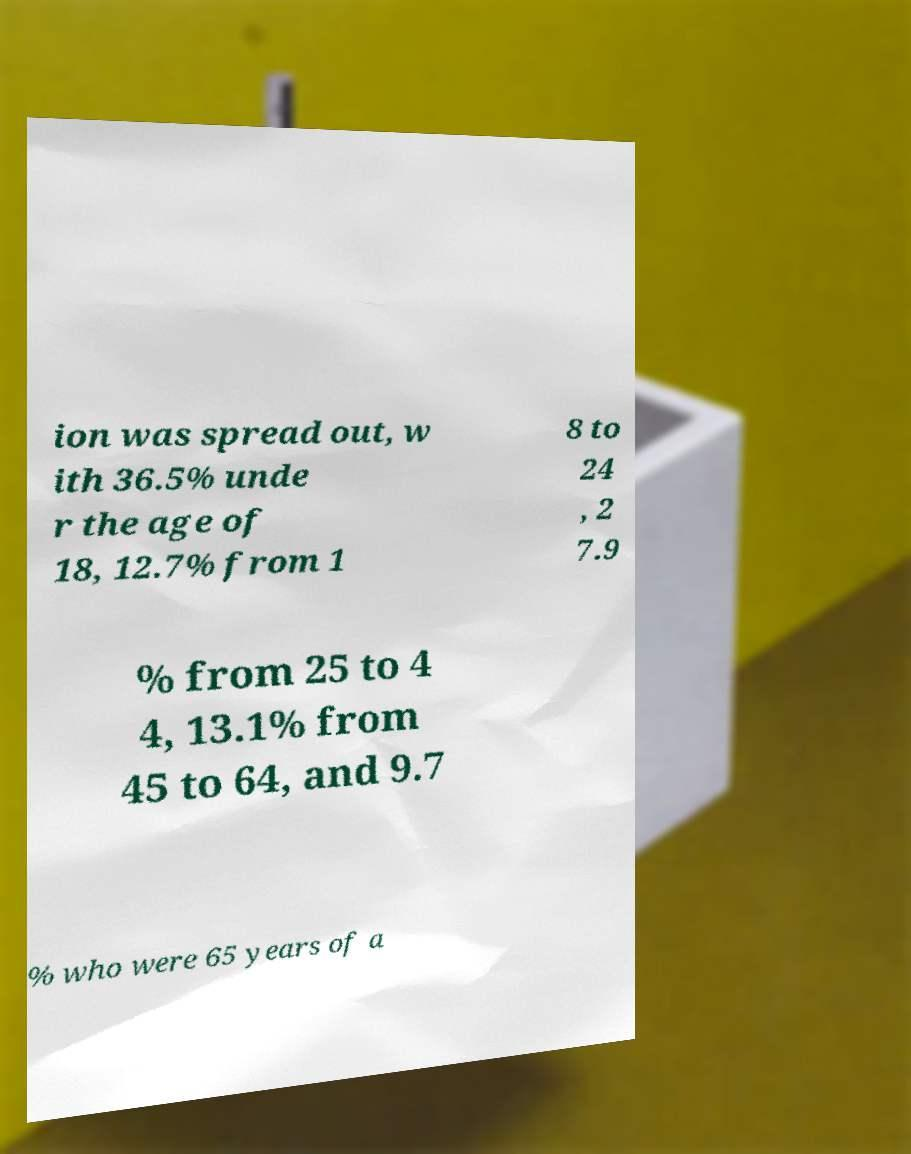Could you assist in decoding the text presented in this image and type it out clearly? ion was spread out, w ith 36.5% unde r the age of 18, 12.7% from 1 8 to 24 , 2 7.9 % from 25 to 4 4, 13.1% from 45 to 64, and 9.7 % who were 65 years of a 